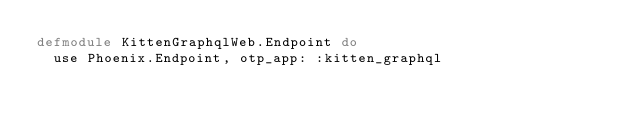Convert code to text. <code><loc_0><loc_0><loc_500><loc_500><_Elixir_>defmodule KittenGraphqlWeb.Endpoint do
  use Phoenix.Endpoint, otp_app: :kitten_graphql</code> 